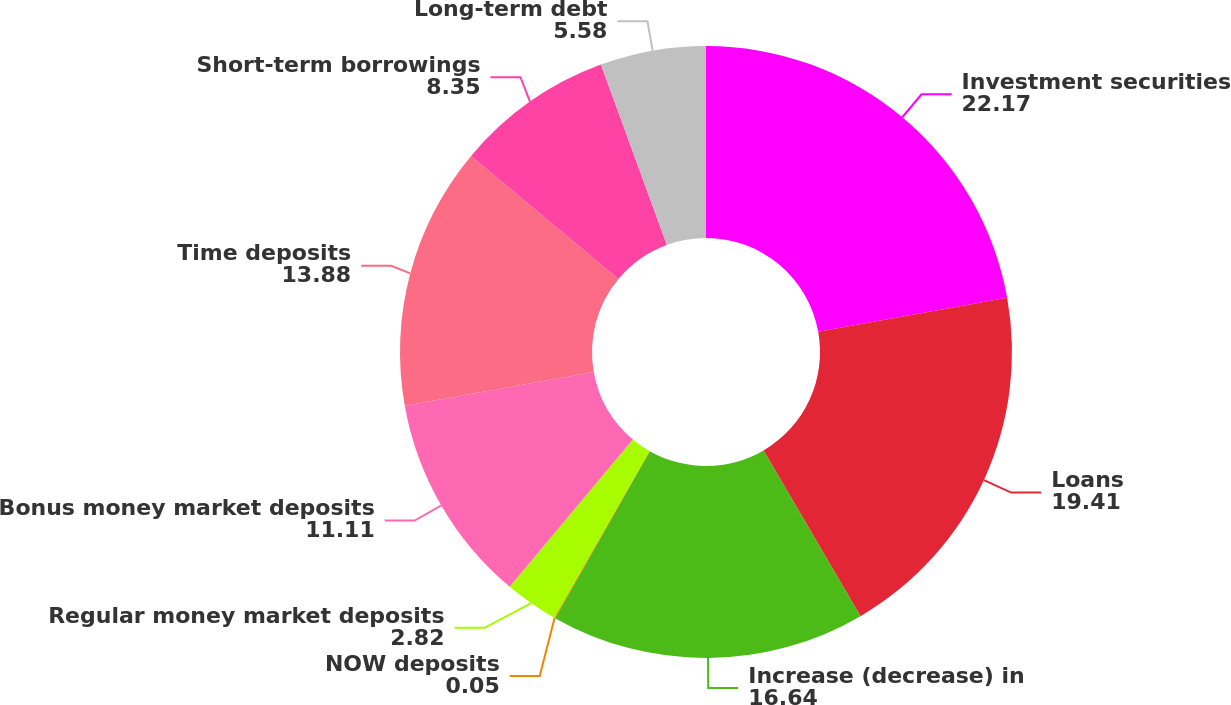Convert chart. <chart><loc_0><loc_0><loc_500><loc_500><pie_chart><fcel>Investment securities<fcel>Loans<fcel>Increase (decrease) in<fcel>NOW deposits<fcel>Regular money market deposits<fcel>Bonus money market deposits<fcel>Time deposits<fcel>Short-term borrowings<fcel>Long-term debt<nl><fcel>22.17%<fcel>19.41%<fcel>16.64%<fcel>0.05%<fcel>2.82%<fcel>11.11%<fcel>13.88%<fcel>8.35%<fcel>5.58%<nl></chart> 